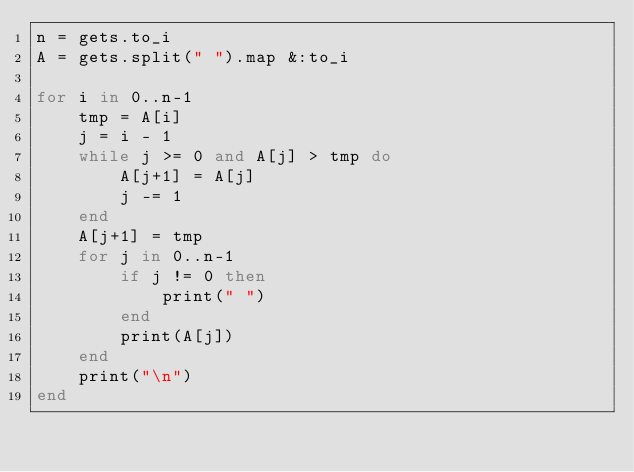Convert code to text. <code><loc_0><loc_0><loc_500><loc_500><_Ruby_>n = gets.to_i
A = gets.split(" ").map &:to_i

for i in 0..n-1
    tmp = A[i]
    j = i - 1
    while j >= 0 and A[j] > tmp do
        A[j+1] = A[j]
        j -= 1
    end
    A[j+1] = tmp
    for j in 0..n-1
        if j != 0 then
            print(" ")
        end
        print(A[j])
    end
    print("\n")
end


</code> 